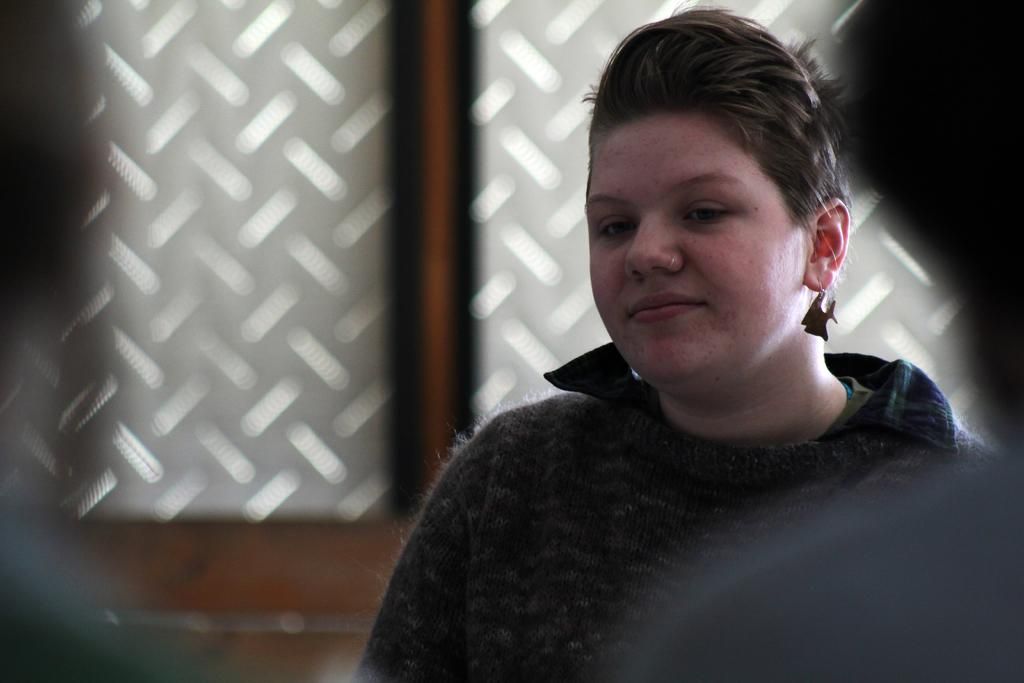What is the person in the image doing? The person is sitting in the image. What is the person wearing? The person is wearing a black dress. What can be seen in the background of the image? There are objects in the background of the image. What is the color of the objects in the background? The objects in the background are white in color. How does the person's health affect their ability to drive in the image? There is no information about the person's health or any indication of driving in the image. 